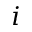Convert formula to latex. <formula><loc_0><loc_0><loc_500><loc_500>i</formula> 